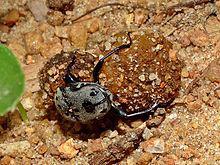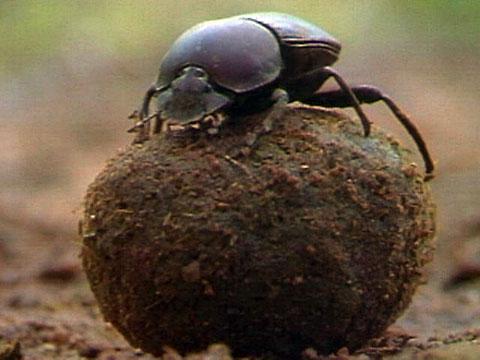The first image is the image on the left, the second image is the image on the right. Examine the images to the left and right. Is the description "There are two black dung beetles touching both the ground and the dung circle." accurate? Answer yes or no. No. The first image is the image on the left, the second image is the image on the right. Given the left and right images, does the statement "There is more than four beetles." hold true? Answer yes or no. No. 